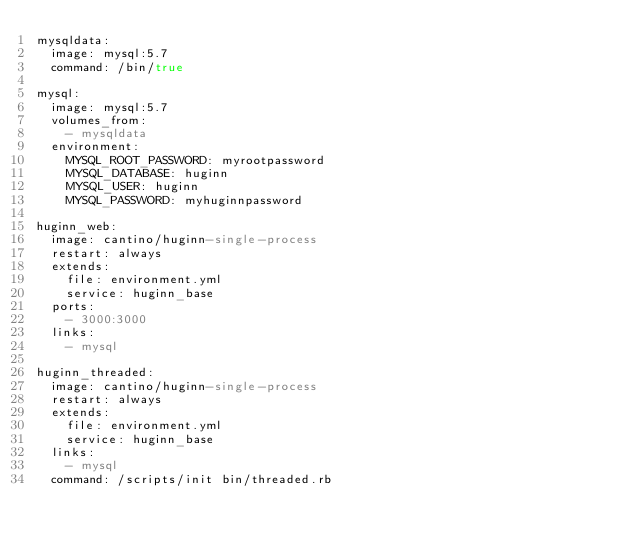<code> <loc_0><loc_0><loc_500><loc_500><_YAML_>mysqldata:
  image: mysql:5.7
  command: /bin/true

mysql:
  image: mysql:5.7
  volumes_from:
    - mysqldata
  environment:
    MYSQL_ROOT_PASSWORD: myrootpassword
    MYSQL_DATABASE: huginn
    MYSQL_USER: huginn
    MYSQL_PASSWORD: myhuginnpassword

huginn_web:
  image: cantino/huginn-single-process
  restart: always
  extends:
    file: environment.yml
    service: huginn_base
  ports:
    - 3000:3000
  links:
    - mysql

huginn_threaded:
  image: cantino/huginn-single-process
  restart: always
  extends:
    file: environment.yml
    service: huginn_base
  links:
    - mysql
  command: /scripts/init bin/threaded.rb

</code> 